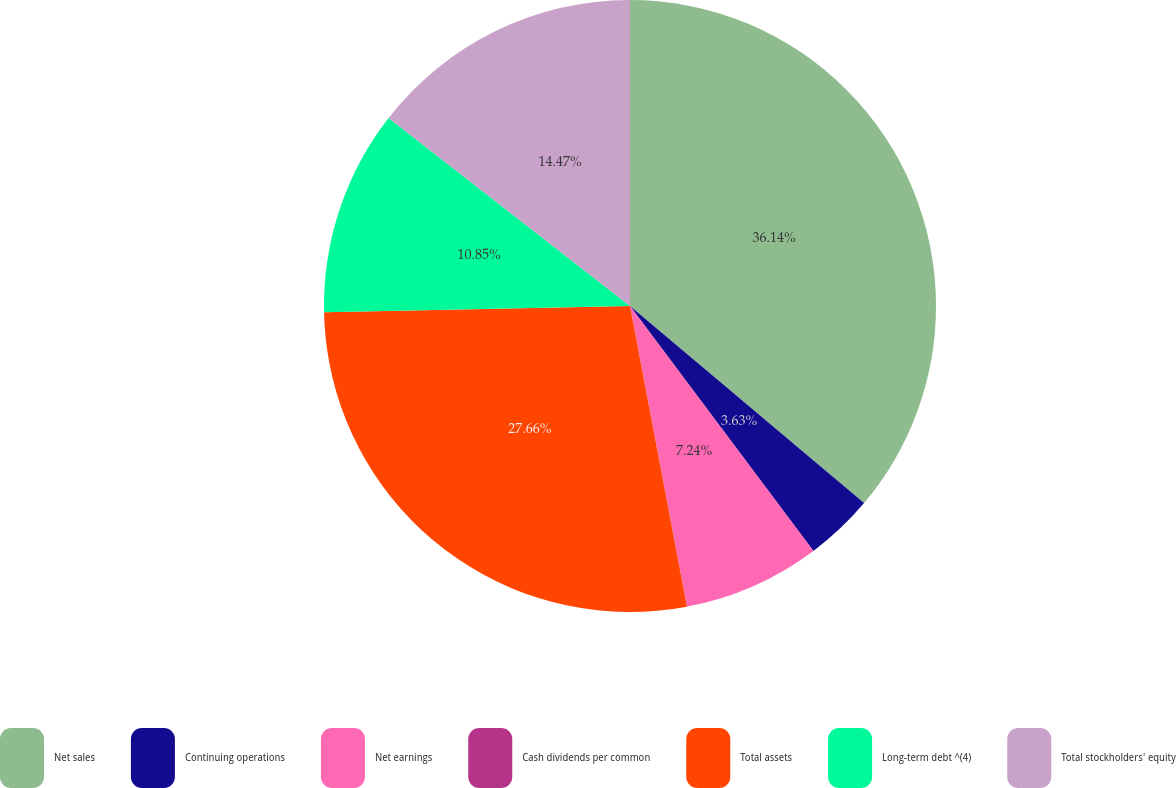Convert chart to OTSL. <chart><loc_0><loc_0><loc_500><loc_500><pie_chart><fcel>Net sales<fcel>Continuing operations<fcel>Net earnings<fcel>Cash dividends per common<fcel>Total assets<fcel>Long-term debt ^(4)<fcel>Total stockholders' equity<nl><fcel>36.14%<fcel>3.63%<fcel>7.24%<fcel>0.01%<fcel>27.66%<fcel>10.85%<fcel>14.47%<nl></chart> 